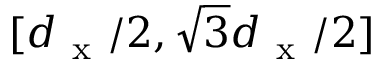Convert formula to latex. <formula><loc_0><loc_0><loc_500><loc_500>[ d _ { x } / 2 , \sqrt { 3 } d _ { x } / 2 ]</formula> 